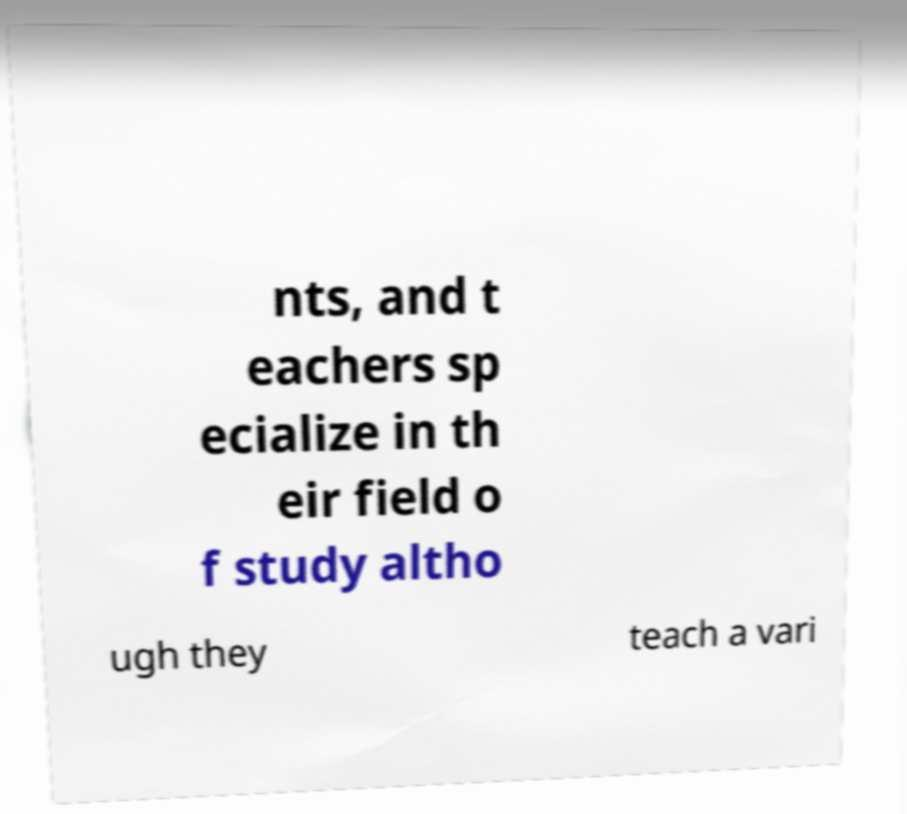Could you extract and type out the text from this image? nts, and t eachers sp ecialize in th eir field o f study altho ugh they teach a vari 